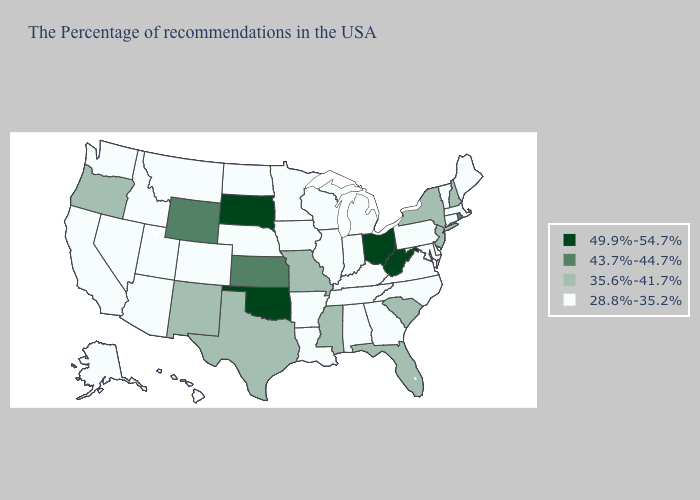What is the value of New Jersey?
Short answer required. 35.6%-41.7%. Does Rhode Island have the highest value in the Northeast?
Give a very brief answer. Yes. Name the states that have a value in the range 49.9%-54.7%?
Short answer required. West Virginia, Ohio, Oklahoma, South Dakota. What is the value of South Dakota?
Give a very brief answer. 49.9%-54.7%. What is the lowest value in states that border Idaho?
Short answer required. 28.8%-35.2%. Among the states that border Nebraska , which have the lowest value?
Concise answer only. Iowa, Colorado. Does Minnesota have the lowest value in the USA?
Answer briefly. Yes. Does South Dakota have the lowest value in the USA?
Quick response, please. No. What is the value of New York?
Concise answer only. 35.6%-41.7%. What is the lowest value in states that border New Mexico?
Answer briefly. 28.8%-35.2%. Among the states that border Maryland , does West Virginia have the highest value?
Quick response, please. Yes. What is the value of Wisconsin?
Give a very brief answer. 28.8%-35.2%. Is the legend a continuous bar?
Short answer required. No. Name the states that have a value in the range 43.7%-44.7%?
Be succinct. Rhode Island, Kansas, Wyoming. Among the states that border Washington , which have the lowest value?
Short answer required. Idaho. 